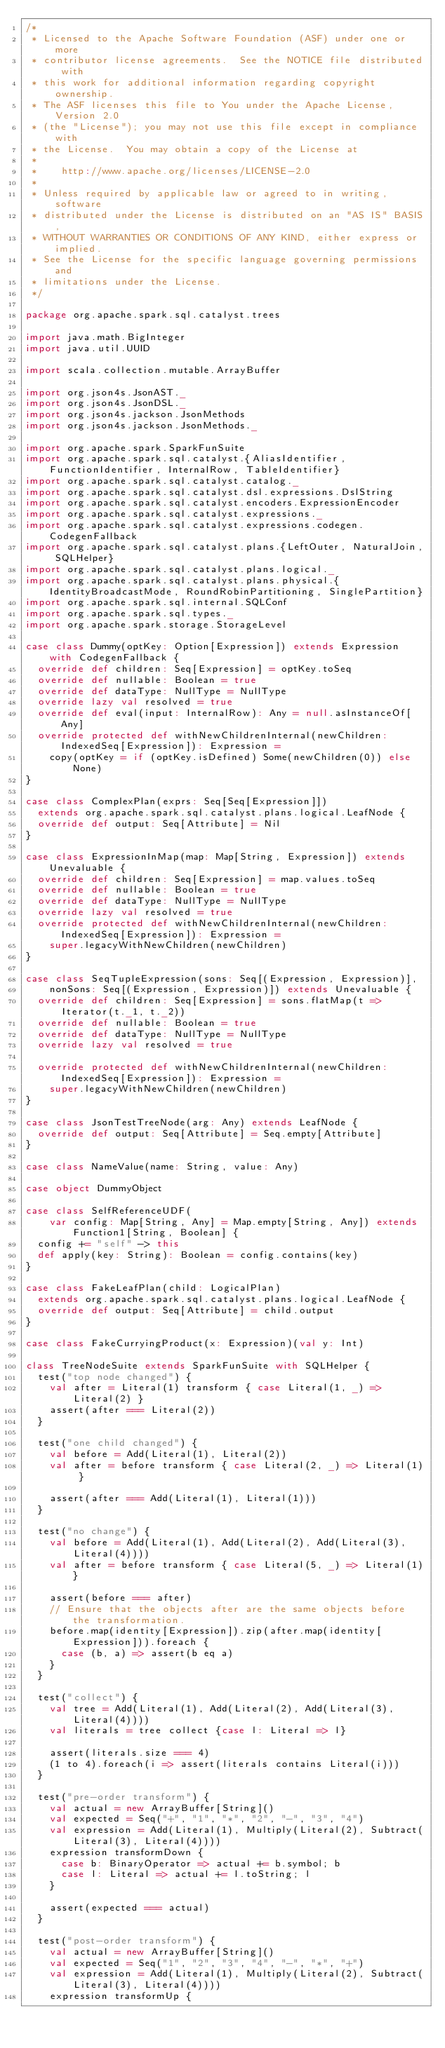<code> <loc_0><loc_0><loc_500><loc_500><_Scala_>/*
 * Licensed to the Apache Software Foundation (ASF) under one or more
 * contributor license agreements.  See the NOTICE file distributed with
 * this work for additional information regarding copyright ownership.
 * The ASF licenses this file to You under the Apache License, Version 2.0
 * (the "License"); you may not use this file except in compliance with
 * the License.  You may obtain a copy of the License at
 *
 *    http://www.apache.org/licenses/LICENSE-2.0
 *
 * Unless required by applicable law or agreed to in writing, software
 * distributed under the License is distributed on an "AS IS" BASIS,
 * WITHOUT WARRANTIES OR CONDITIONS OF ANY KIND, either express or implied.
 * See the License for the specific language governing permissions and
 * limitations under the License.
 */

package org.apache.spark.sql.catalyst.trees

import java.math.BigInteger
import java.util.UUID

import scala.collection.mutable.ArrayBuffer

import org.json4s.JsonAST._
import org.json4s.JsonDSL._
import org.json4s.jackson.JsonMethods
import org.json4s.jackson.JsonMethods._

import org.apache.spark.SparkFunSuite
import org.apache.spark.sql.catalyst.{AliasIdentifier, FunctionIdentifier, InternalRow, TableIdentifier}
import org.apache.spark.sql.catalyst.catalog._
import org.apache.spark.sql.catalyst.dsl.expressions.DslString
import org.apache.spark.sql.catalyst.encoders.ExpressionEncoder
import org.apache.spark.sql.catalyst.expressions._
import org.apache.spark.sql.catalyst.expressions.codegen.CodegenFallback
import org.apache.spark.sql.catalyst.plans.{LeftOuter, NaturalJoin, SQLHelper}
import org.apache.spark.sql.catalyst.plans.logical._
import org.apache.spark.sql.catalyst.plans.physical.{IdentityBroadcastMode, RoundRobinPartitioning, SinglePartition}
import org.apache.spark.sql.internal.SQLConf
import org.apache.spark.sql.types._
import org.apache.spark.storage.StorageLevel

case class Dummy(optKey: Option[Expression]) extends Expression with CodegenFallback {
  override def children: Seq[Expression] = optKey.toSeq
  override def nullable: Boolean = true
  override def dataType: NullType = NullType
  override lazy val resolved = true
  override def eval(input: InternalRow): Any = null.asInstanceOf[Any]
  override protected def withNewChildrenInternal(newChildren: IndexedSeq[Expression]): Expression =
    copy(optKey = if (optKey.isDefined) Some(newChildren(0)) else None)
}

case class ComplexPlan(exprs: Seq[Seq[Expression]])
  extends org.apache.spark.sql.catalyst.plans.logical.LeafNode {
  override def output: Seq[Attribute] = Nil
}

case class ExpressionInMap(map: Map[String, Expression]) extends Unevaluable {
  override def children: Seq[Expression] = map.values.toSeq
  override def nullable: Boolean = true
  override def dataType: NullType = NullType
  override lazy val resolved = true
  override protected def withNewChildrenInternal(newChildren: IndexedSeq[Expression]): Expression =
    super.legacyWithNewChildren(newChildren)
}

case class SeqTupleExpression(sons: Seq[(Expression, Expression)],
    nonSons: Seq[(Expression, Expression)]) extends Unevaluable {
  override def children: Seq[Expression] = sons.flatMap(t => Iterator(t._1, t._2))
  override def nullable: Boolean = true
  override def dataType: NullType = NullType
  override lazy val resolved = true

  override protected def withNewChildrenInternal(newChildren: IndexedSeq[Expression]): Expression =
    super.legacyWithNewChildren(newChildren)
}

case class JsonTestTreeNode(arg: Any) extends LeafNode {
  override def output: Seq[Attribute] = Seq.empty[Attribute]
}

case class NameValue(name: String, value: Any)

case object DummyObject

case class SelfReferenceUDF(
    var config: Map[String, Any] = Map.empty[String, Any]) extends Function1[String, Boolean] {
  config += "self" -> this
  def apply(key: String): Boolean = config.contains(key)
}

case class FakeLeafPlan(child: LogicalPlan)
  extends org.apache.spark.sql.catalyst.plans.logical.LeafNode {
  override def output: Seq[Attribute] = child.output
}

case class FakeCurryingProduct(x: Expression)(val y: Int)

class TreeNodeSuite extends SparkFunSuite with SQLHelper {
  test("top node changed") {
    val after = Literal(1) transform { case Literal(1, _) => Literal(2) }
    assert(after === Literal(2))
  }

  test("one child changed") {
    val before = Add(Literal(1), Literal(2))
    val after = before transform { case Literal(2, _) => Literal(1) }

    assert(after === Add(Literal(1), Literal(1)))
  }

  test("no change") {
    val before = Add(Literal(1), Add(Literal(2), Add(Literal(3), Literal(4))))
    val after = before transform { case Literal(5, _) => Literal(1)}

    assert(before === after)
    // Ensure that the objects after are the same objects before the transformation.
    before.map(identity[Expression]).zip(after.map(identity[Expression])).foreach {
      case (b, a) => assert(b eq a)
    }
  }

  test("collect") {
    val tree = Add(Literal(1), Add(Literal(2), Add(Literal(3), Literal(4))))
    val literals = tree collect {case l: Literal => l}

    assert(literals.size === 4)
    (1 to 4).foreach(i => assert(literals contains Literal(i)))
  }

  test("pre-order transform") {
    val actual = new ArrayBuffer[String]()
    val expected = Seq("+", "1", "*", "2", "-", "3", "4")
    val expression = Add(Literal(1), Multiply(Literal(2), Subtract(Literal(3), Literal(4))))
    expression transformDown {
      case b: BinaryOperator => actual += b.symbol; b
      case l: Literal => actual += l.toString; l
    }

    assert(expected === actual)
  }

  test("post-order transform") {
    val actual = new ArrayBuffer[String]()
    val expected = Seq("1", "2", "3", "4", "-", "*", "+")
    val expression = Add(Literal(1), Multiply(Literal(2), Subtract(Literal(3), Literal(4))))
    expression transformUp {</code> 